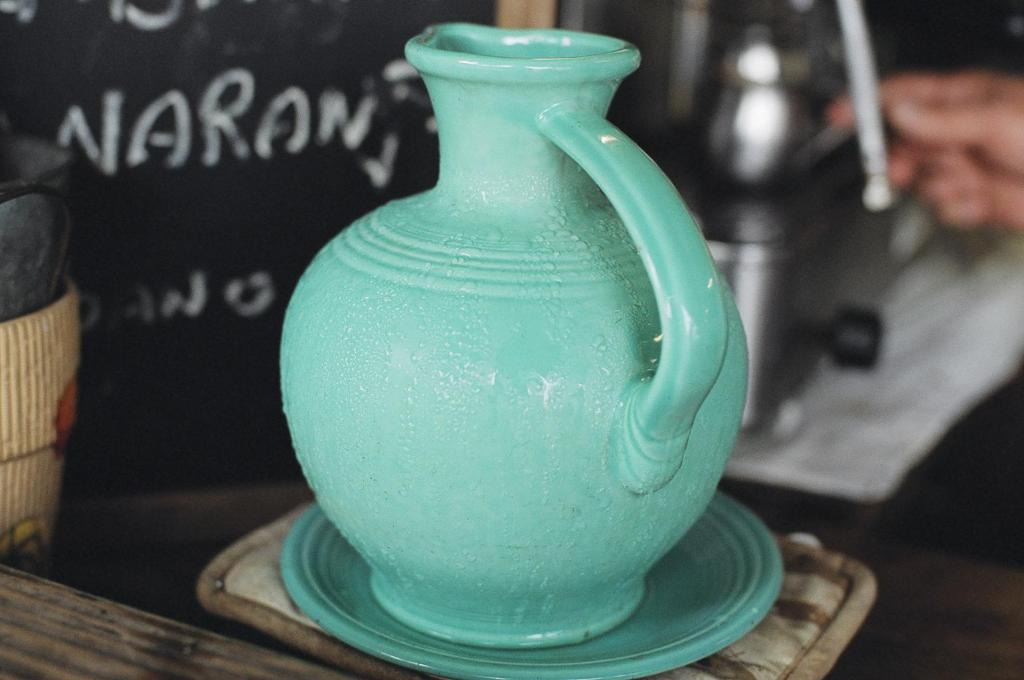What object is present in the image? There is a pot in the image. Can you describe any other elements in the image? A person's hand is visible in the image. What is the comparison between the pot and the motion of the person's hand in the image? There is no motion of the person's hand in the image, and therefore no comparison can be made between the pot and the motion of the hand. 